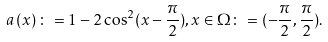<formula> <loc_0><loc_0><loc_500><loc_500>a \left ( x \right ) \colon = 1 - 2 \cos ^ { 2 } ( x - \frac { \pi } { 2 } ) , x \in \Omega \colon = ( - \frac { \pi } { 2 } , \frac { \pi } { 2 } ) .</formula> 